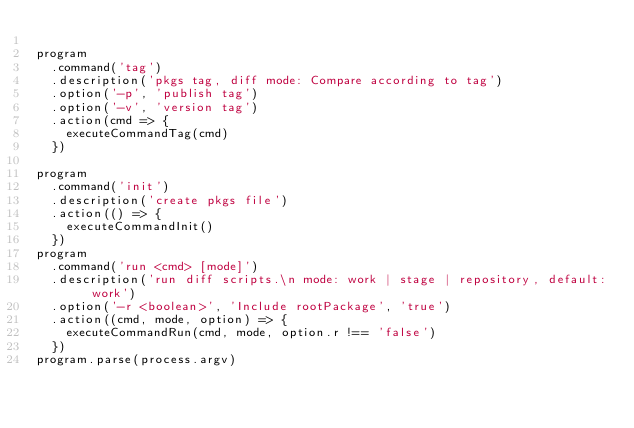Convert code to text. <code><loc_0><loc_0><loc_500><loc_500><_JavaScript_>
program
  .command('tag')
  .description('pkgs tag, diff mode: Compare according to tag')
  .option('-p', 'publish tag')
  .option('-v', 'version tag')
  .action(cmd => {
    executeCommandTag(cmd)
  })

program
  .command('init')
  .description('create pkgs file')
  .action(() => {
    executeCommandInit()
  })
program
  .command('run <cmd> [mode]')
  .description('run diff scripts.\n mode: work | stage | repository, default: work')
  .option('-r <boolean>', 'Include rootPackage', 'true')
  .action((cmd, mode, option) => {
    executeCommandRun(cmd, mode, option.r !== 'false')
  })
program.parse(process.argv)
</code> 